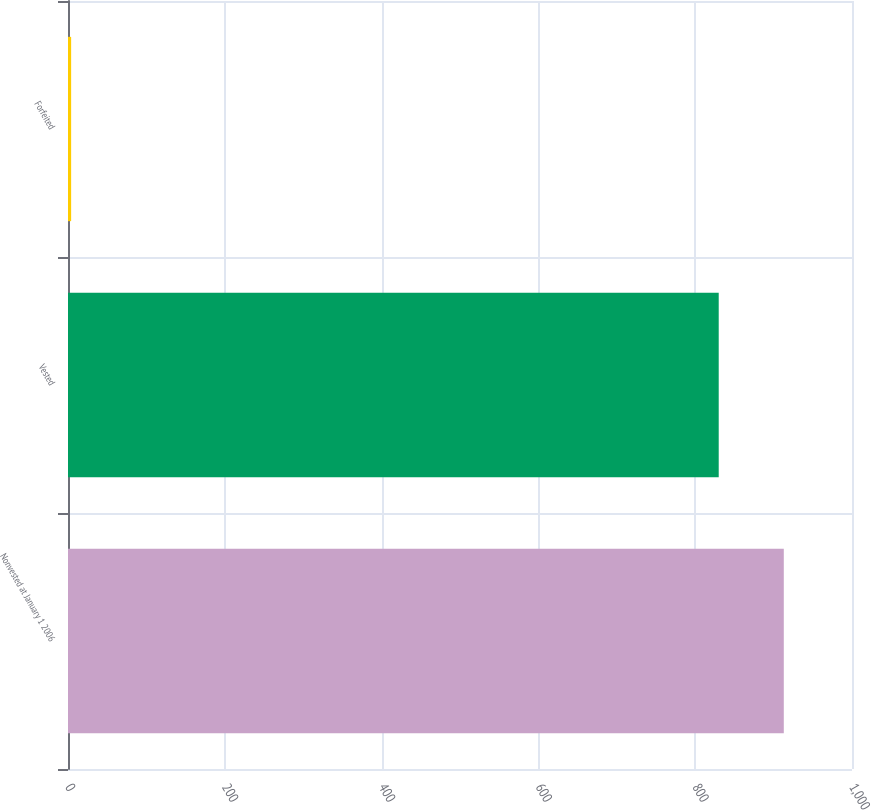Convert chart. <chart><loc_0><loc_0><loc_500><loc_500><bar_chart><fcel>Nonvested at January 1 2006<fcel>Vested<fcel>Forfeited<nl><fcel>913<fcel>830<fcel>4<nl></chart> 